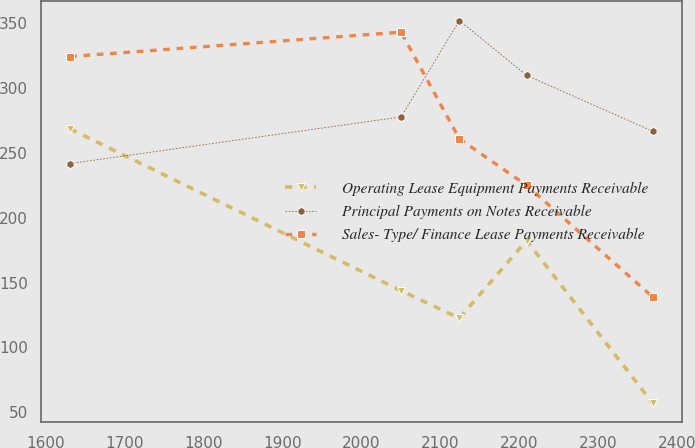Convert chart to OTSL. <chart><loc_0><loc_0><loc_500><loc_500><line_chart><ecel><fcel>Operating Lease Equipment Payments Receivable<fcel>Principal Payments on Notes Receivable<fcel>Sales- Type/ Finance Lease Payments Receivable<nl><fcel>1630.8<fcel>268.39<fcel>241.68<fcel>324.15<nl><fcel>2050.32<fcel>143.69<fcel>277.61<fcel>342.91<nl><fcel>2124.16<fcel>122.56<fcel>351.86<fcel>260.74<nl><fcel>2209.31<fcel>182.33<fcel>309.6<fcel>224.93<nl><fcel>2369.2<fcel>57.05<fcel>266.59<fcel>138.88<nl></chart> 